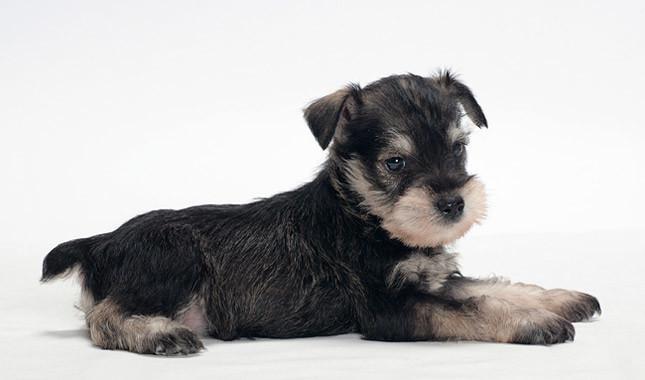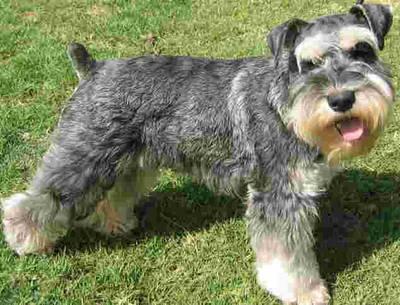The first image is the image on the left, the second image is the image on the right. Assess this claim about the two images: "At least one of the dogs is indoors.". Correct or not? Answer yes or no. Yes. 